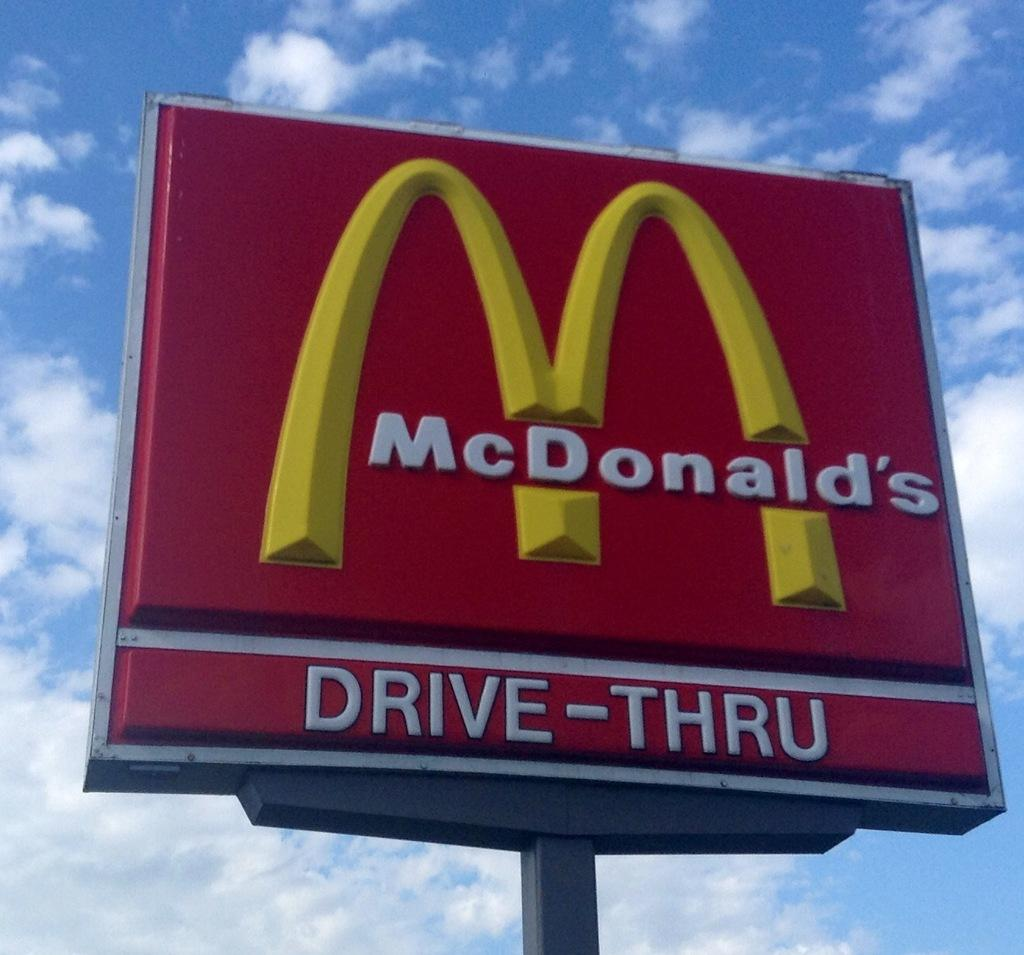Provide a one-sentence caption for the provided image. A outdoor red sign for the fast food restaurant "McDonald's". 